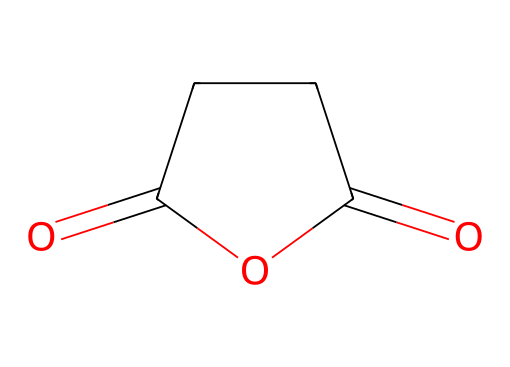What is the name of this compound? The SMILES representation corresponds to the structure of succinic anhydride, which is an acid anhydride derived from succinic acid.
Answer: succinic anhydride How many carbon atoms are in the structure? By analyzing the SMILES, we can see that there are four carbon atoms present in the cyclized structure of the anhydride.
Answer: 4 What are the types of functional groups present in this compound? The structure contains two carbonyl groups (C=O) and one cyclic structure, which indicates the presence of an anhydride functional group.
Answer: anhydride, carbonyl How many oxygen atoms are present in the chemical structure? In the given SMILES representation, there are a total of three oxygen atoms: two in carbonyl groups and one that is part of the anhydride ring.
Answer: 3 What type of reaction can succinic anhydride participate in? Being an anhydride, it can easily undergo hydrolysis to form succinic acid when reacting with water.
Answer: hydrolysis Why is succinic anhydride utilized in pharmaceutical synthesis? Succinic anhydride is used as an intermediate due to its ability to react with various nucleophiles, enhancing drug development processes.
Answer: intermediate 